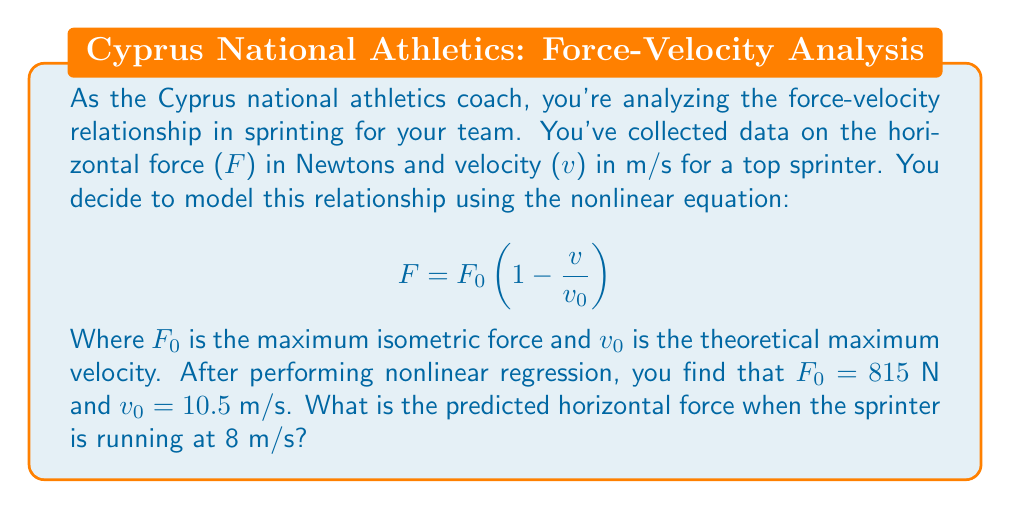Could you help me with this problem? To solve this problem, we'll follow these steps:

1. Identify the given information:
   - The nonlinear equation: $F = F_0 (1 - \frac{v}{v_0})$
   - $F_0 = 815$ N (maximum isometric force)
   - $v_0 = 10.5$ m/s (theoretical maximum velocity)
   - We need to find F when v = 8 m/s

2. Substitute the known values into the equation:
   $$F = 815 (1 - \frac{8}{10.5})$$

3. Simplify the fraction inside the parentheses:
   $$F = 815 (1 - \frac{16}{21})$$

4. Perform the subtraction inside the parentheses:
   $$F = 815 (\frac{5}{21})$$

5. Multiply the values:
   $$F = \frac{815 \times 5}{21}$$

6. Calculate the final result:
   $$F = 194.05 \text{ N}$$

Therefore, the predicted horizontal force when the sprinter is running at 8 m/s is approximately 194.05 N.
Answer: 194.05 N 